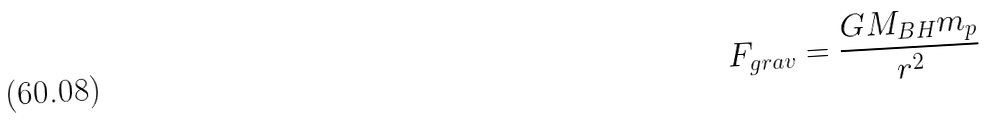<formula> <loc_0><loc_0><loc_500><loc_500>F _ { g r a v } = \frac { G M _ { B H } m _ { p } } { r ^ { 2 } }</formula> 